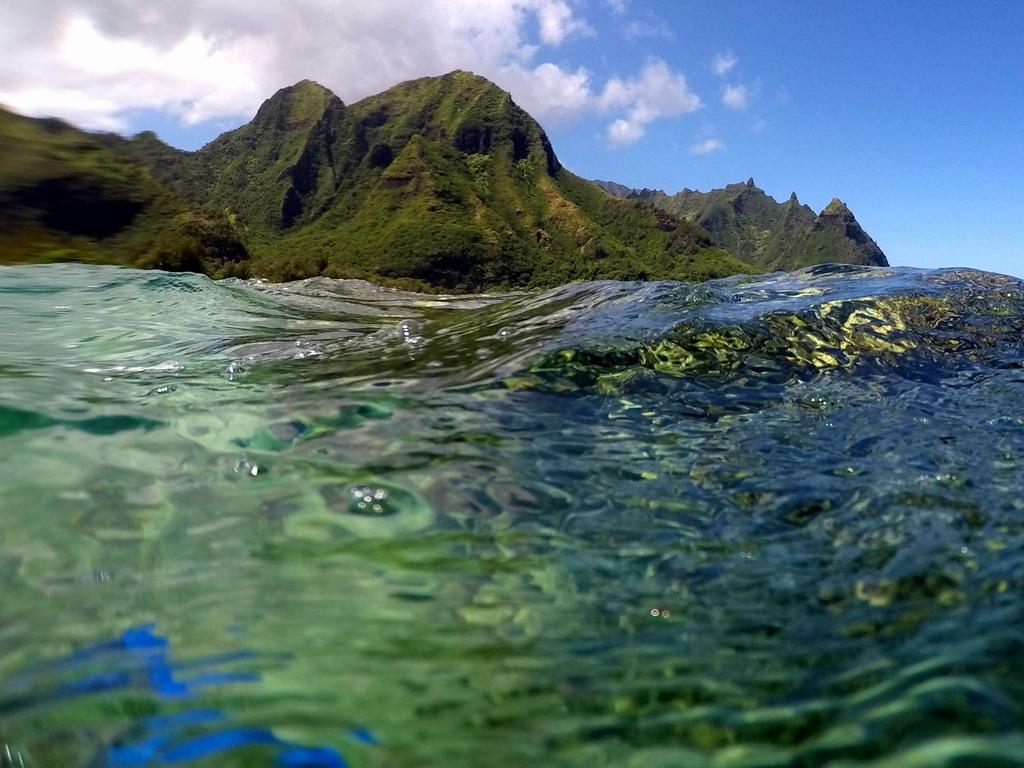What type of natural landform can be seen in the image? There are mountains in the image. What is located at the bottom of the image? There is water at the bottom of the image. What can be observed on the surface of the water? Reflections are visible on the water. What is visible at the top of the image? The sky is visible at the top of the image. How many brothers are visible in the image? There are no brothers present in the image. What type of fruit can be seen growing on the mountains in the image? There is no fruit visible in the image; it features mountains, water, reflections, and the sky. 